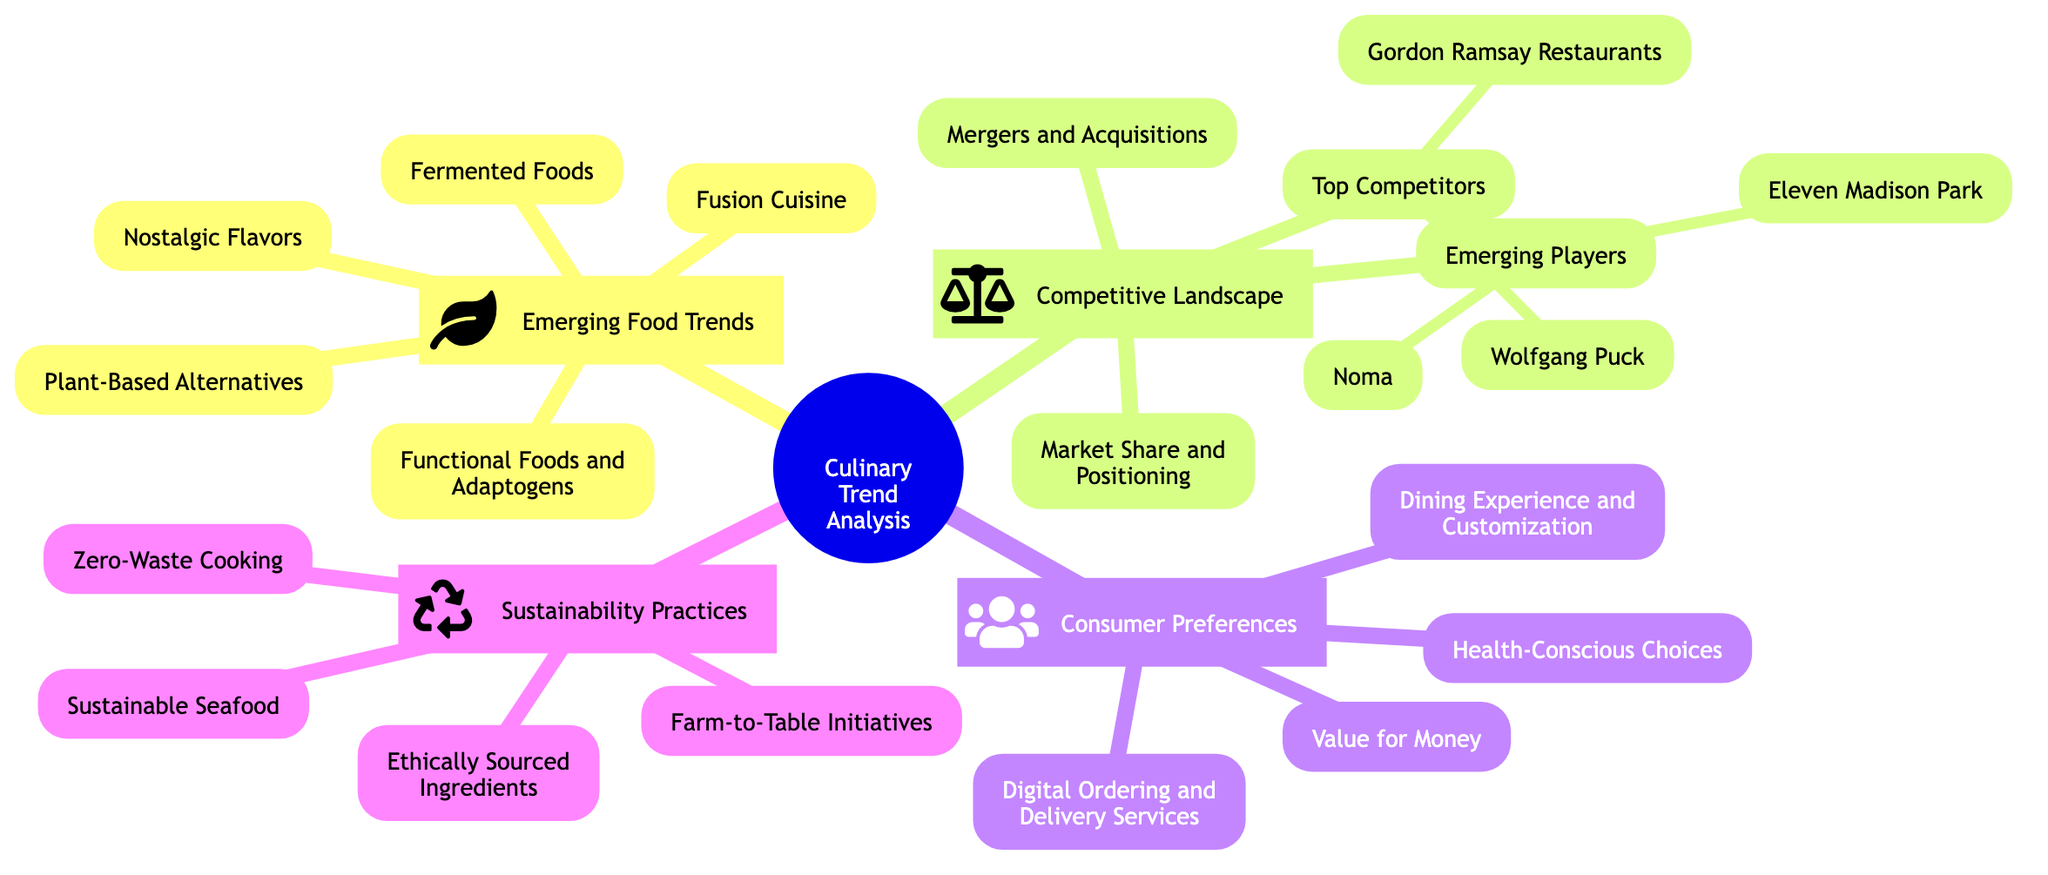What are the five emerging food trends listed? The diagram contains a section labeled "Emerging Food Trends" which lists five specific sub-elements underneath it. These are "Plant-Based Alternatives," "Fermented Foods," "Functional Foods and Adaptogens," "Nostalgic Flavors," and "Fusion Cuisine."
Answer: Plant-Based Alternatives, Fermented Foods, Functional Foods and Adaptogens, Nostalgic Flavors, Fusion Cuisine Who are the top competitors in the competitive landscape? Under the "Competitive Landscape" section, there is a sub-node for "Top Competitors" that explicitly names two entities: "Gordon Ramsay Restaurants" and "Wolfgang Puck."
Answer: Gordon Ramsay Restaurants, Wolfgang Puck How many sub-elements are listed under sustainability practices? The "Sustainability Practices" section has four specific sub-elements detailing different sustainable approaches, which are "Farm-to-Table Initiatives," "Zero-Waste Cooking," "Sustainable Seafood," and "Ethically Sourced Ingredients." Therefore, the number is four.
Answer: 4 Which emerging player is mentioned in the competitive landscape? In the "Competitive Landscape" section, there is a sub-node titled "Emerging Players" that mentions two specific entities, one of which is "Eleven Madison Park."
Answer: Eleven Madison Park What aspect of consumer preferences focuses on health? Within the "Consumer Preferences" section of the diagram, one of the sub-elements explicitly focuses on health as "Health-Conscious Choices." This reflects the trend towards preferences influenced by health considerations.
Answer: Health-Conscious Choices Which sub-element under emerging food trends combines cuisines? The sub-element "Fusion Cuisine" in the "Emerging Food Trends" section pertains to the combination of different culinary traditions, indicating a trend of creating dishes that merge various cultural cuisines.
Answer: Fusion Cuisine Identify a sustainability practice related to waste. In the "Sustainability Practices" section, the sub-element "Zero-Waste Cooking" specifically addresses methods of minimizing waste in culinary practices, focusing on sustainability efforts in the kitchen.
Answer: Zero-Waste Cooking How are the competitors in the competitive landscape categorized? The competitors in the "Competitive Landscape" section are categorized into "Top Competitors" and "Emerging Players," which allows for a clear distinction between established enterprises and newly rising competitors.
Answer: Top Competitors, Emerging Players Which consumer preference relates to meal personalization? In the "Consumer Preferences" section, "Dining Experience and Customization" highlights the trend towards personalized meal experiences, focusing on what consumers desire in terms of meal preparation and consumption.
Answer: Dining Experience and Customization 